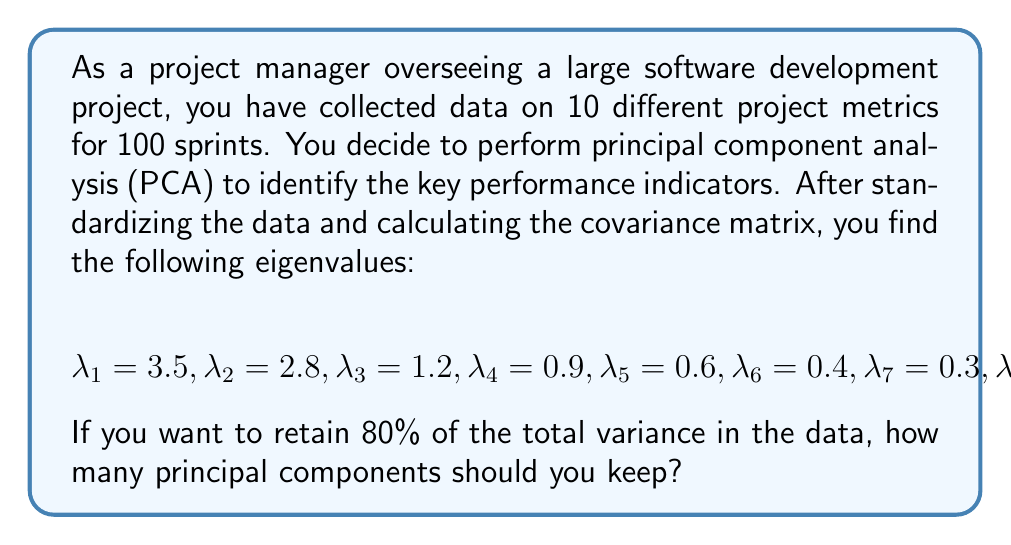Provide a solution to this math problem. To solve this problem, we need to follow these steps:

1) Calculate the total variance:
   The total variance is the sum of all eigenvalues.
   $$\text{Total Variance} = \sum_{i=1}^{10} \lambda_i = 3.5 + 2.8 + 1.2 + 0.9 + 0.6 + 0.4 + 0.3 + 0.2 + 0.1 + 0.0 = 10$$

2) Calculate the cumulative proportion of variance for each principal component:
   For each principal component, we calculate:
   $$\text{Cumulative Proportion} = \frac{\sum_{i=1}^{k} \lambda_i}{\text{Total Variance}}$$
   where $k$ is the number of components we're considering.

3) Find the number of components that retain at least 80% of the variance:

   For 1 component: $\frac{3.5}{10} = 0.35$ or 35%
   For 2 components: $\frac{3.5 + 2.8}{10} = 0.63$ or 63%
   For 3 components: $\frac{3.5 + 2.8 + 1.2}{10} = 0.75$ or 75%
   For 4 components: $\frac{3.5 + 2.8 + 1.2 + 0.9}{10} = 0.84$ or 84%

4) The first three components retain less than 80% of the variance, but the first four components retain more than 80%.

Therefore, we need to keep 4 principal components to retain at least 80% of the total variance in the data.
Answer: 4 principal components 